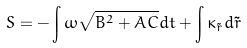<formula> <loc_0><loc_0><loc_500><loc_500>S = - \int \omega \sqrt { B ^ { 2 } + A C } d t + \int \kappa _ { \tilde { r } } d \tilde { r }</formula> 